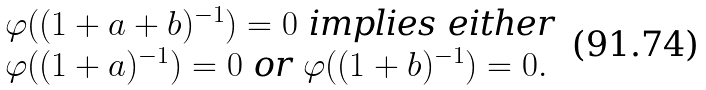<formula> <loc_0><loc_0><loc_500><loc_500>\begin{array} { l l } & \varphi ( ( 1 + a + b ) ^ { - 1 } ) = 0 \text { implies either } \\ & \varphi ( ( 1 + a ) ^ { - 1 } ) = 0 \text { or } \varphi ( ( 1 + b ) ^ { - 1 } ) = 0 . \end{array}</formula> 